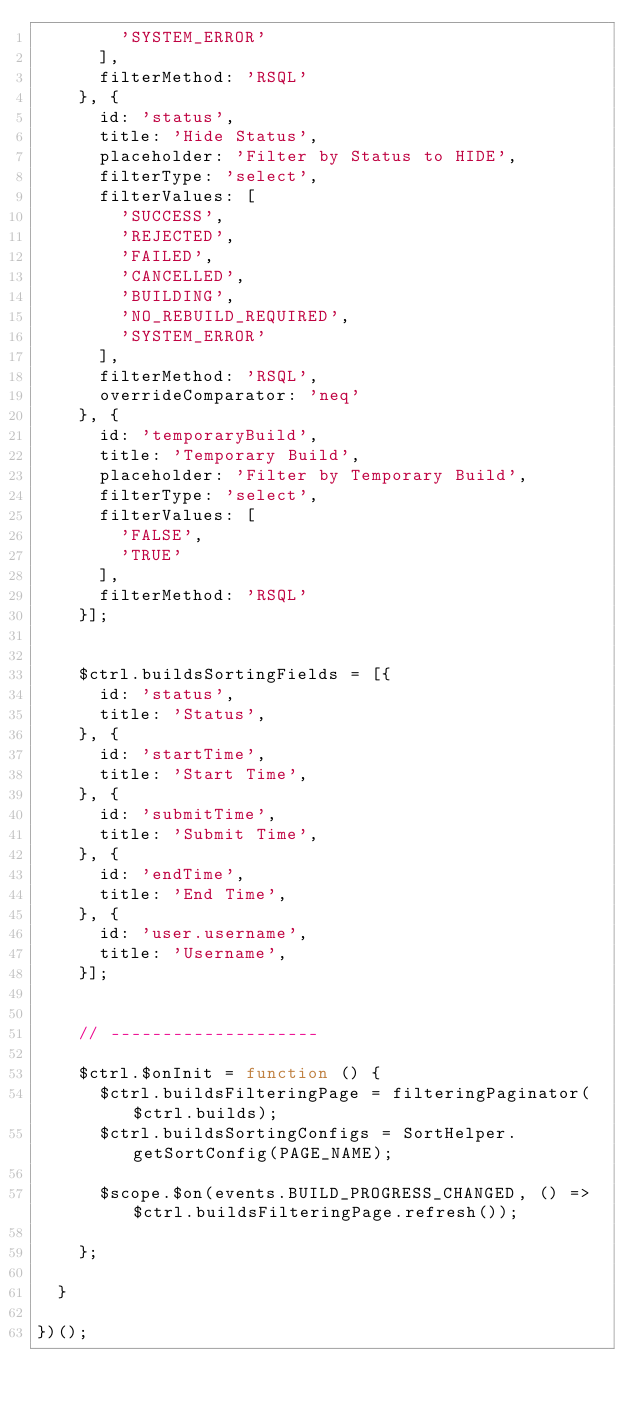Convert code to text. <code><loc_0><loc_0><loc_500><loc_500><_JavaScript_>        'SYSTEM_ERROR'
      ],
      filterMethod: 'RSQL'
    }, {
      id: 'status',
      title: 'Hide Status',
      placeholder: 'Filter by Status to HIDE',
      filterType: 'select',
      filterValues: [
        'SUCCESS',
        'REJECTED',
        'FAILED',
        'CANCELLED',
        'BUILDING',
        'NO_REBUILD_REQUIRED',
        'SYSTEM_ERROR'
      ],
      filterMethod: 'RSQL',
      overrideComparator: 'neq'
    }, {
      id: 'temporaryBuild',
      title: 'Temporary Build',
      placeholder: 'Filter by Temporary Build',
      filterType: 'select',
      filterValues: [
        'FALSE',
        'TRUE'
      ],
      filterMethod: 'RSQL'
    }];


    $ctrl.buildsSortingFields = [{
      id: 'status',
      title: 'Status',
    }, {
      id: 'startTime',
      title: 'Start Time',
    }, {
      id: 'submitTime',
      title: 'Submit Time',
    }, {
      id: 'endTime',
      title: 'End Time',
    }, {
      id: 'user.username',
      title: 'Username',
    }];


    // --------------------

    $ctrl.$onInit = function () {
      $ctrl.buildsFilteringPage = filteringPaginator($ctrl.builds);
      $ctrl.buildsSortingConfigs = SortHelper.getSortConfig(PAGE_NAME);

      $scope.$on(events.BUILD_PROGRESS_CHANGED, () => $ctrl.buildsFilteringPage.refresh());

    };

  }

})();
</code> 